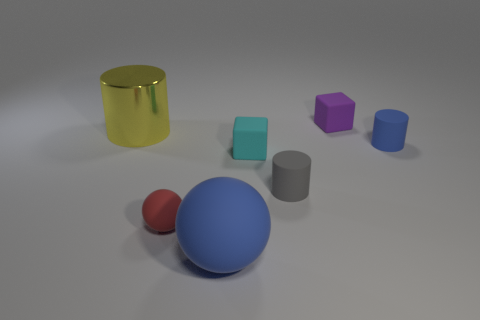Is the number of small purple cubes the same as the number of red metallic objects?
Make the answer very short. No. There is another thing that is the same shape as the tiny cyan thing; what size is it?
Keep it short and to the point. Small. There is a large blue matte object that is in front of the red rubber thing that is to the left of the purple block; how many large blue balls are right of it?
Offer a very short reply. 0. Are there the same number of blocks to the left of the red sphere and tiny blue rubber cylinders?
Your answer should be very brief. No. How many blocks are either red rubber things or cyan things?
Offer a very short reply. 1. Is the shiny cylinder the same color as the large rubber object?
Provide a succinct answer. No. Are there an equal number of things that are on the left side of the blue matte cylinder and big yellow metallic things in front of the metallic thing?
Make the answer very short. No. The large metal object has what color?
Offer a terse response. Yellow. What number of things are either big objects left of the big blue matte ball or small cyan cylinders?
Offer a terse response. 1. Is the size of the cube that is in front of the purple cube the same as the matte block that is behind the big metallic cylinder?
Your response must be concise. Yes. 